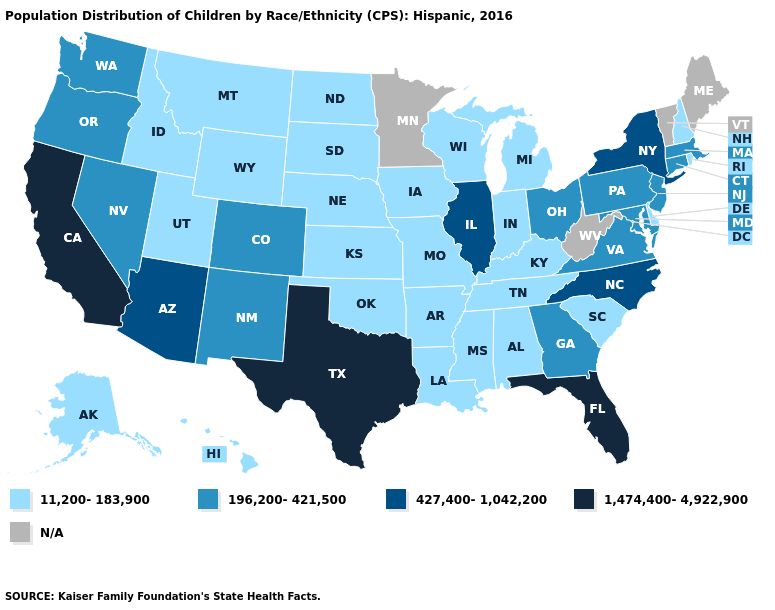Among the states that border New Mexico , which have the highest value?
Concise answer only. Texas. What is the lowest value in the USA?
Answer briefly. 11,200-183,900. Name the states that have a value in the range 11,200-183,900?
Keep it brief. Alabama, Alaska, Arkansas, Delaware, Hawaii, Idaho, Indiana, Iowa, Kansas, Kentucky, Louisiana, Michigan, Mississippi, Missouri, Montana, Nebraska, New Hampshire, North Dakota, Oklahoma, Rhode Island, South Carolina, South Dakota, Tennessee, Utah, Wisconsin, Wyoming. Among the states that border Pennsylvania , does Ohio have the lowest value?
Answer briefly. No. Name the states that have a value in the range 1,474,400-4,922,900?
Answer briefly. California, Florida, Texas. What is the value of Idaho?
Short answer required. 11,200-183,900. What is the highest value in states that border Wyoming?
Write a very short answer. 196,200-421,500. What is the value of West Virginia?
Quick response, please. N/A. Among the states that border Maryland , does Virginia have the lowest value?
Write a very short answer. No. What is the lowest value in states that border Georgia?
Write a very short answer. 11,200-183,900. What is the value of Tennessee?
Quick response, please. 11,200-183,900. Among the states that border Rhode Island , which have the lowest value?
Concise answer only. Connecticut, Massachusetts. Which states have the lowest value in the South?
Concise answer only. Alabama, Arkansas, Delaware, Kentucky, Louisiana, Mississippi, Oklahoma, South Carolina, Tennessee. What is the value of Kansas?
Be succinct. 11,200-183,900. What is the value of Georgia?
Quick response, please. 196,200-421,500. 